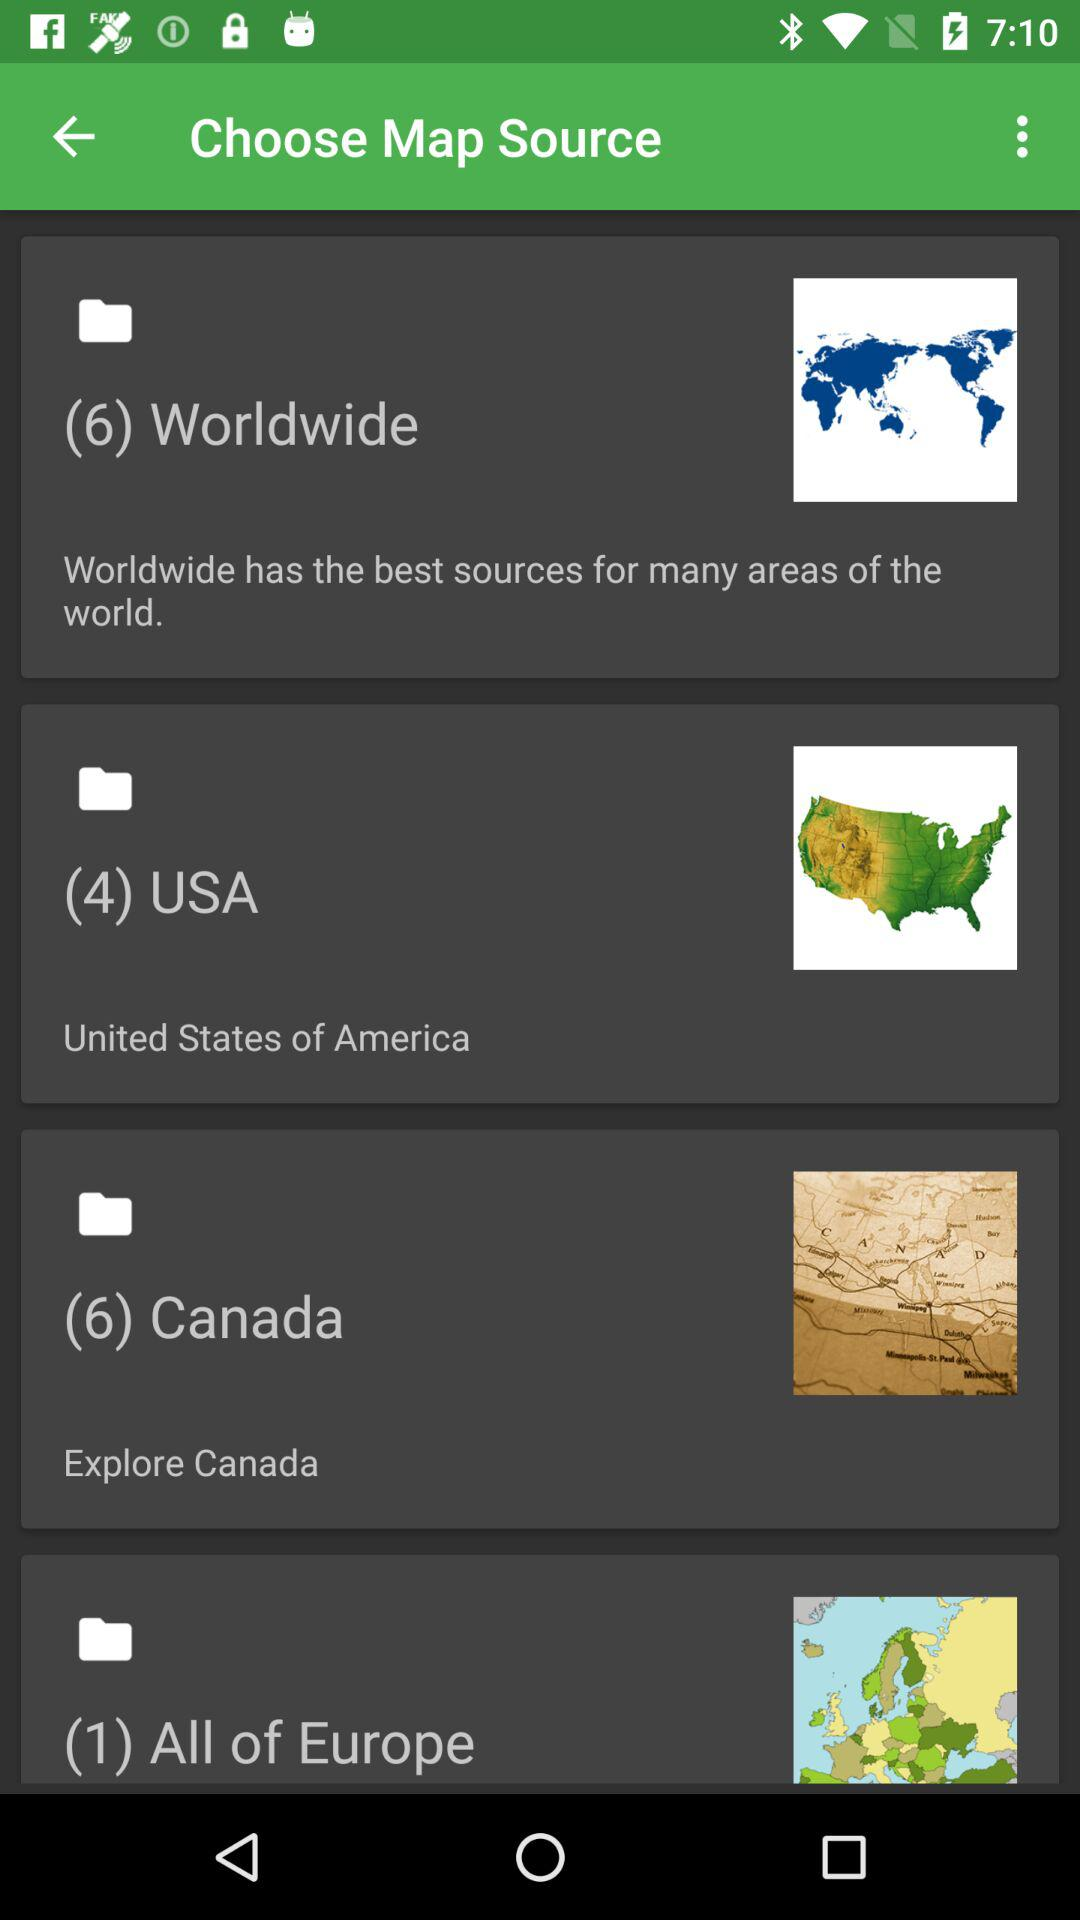Which are the different map sources? The different map sources are "Worldwide", "USA", "Canada" and "All of Europe". 